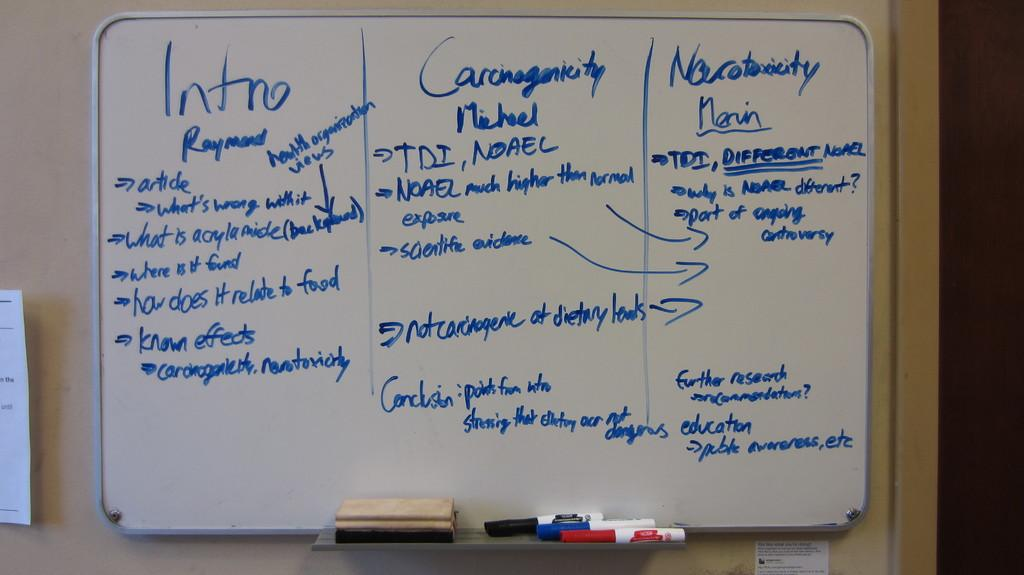What is the main object in the center of the image? There is a white color board in the middle of the image. What can be found at the bottom of the image? There are markers at the bottom of the image. What tool is present in the image for cleaning or erasing? There is a duster in the image. What type of lettuce is being used as a soundproofing material in the image? There is no lettuce present in the image, and it is not being used as a soundproofing material. 